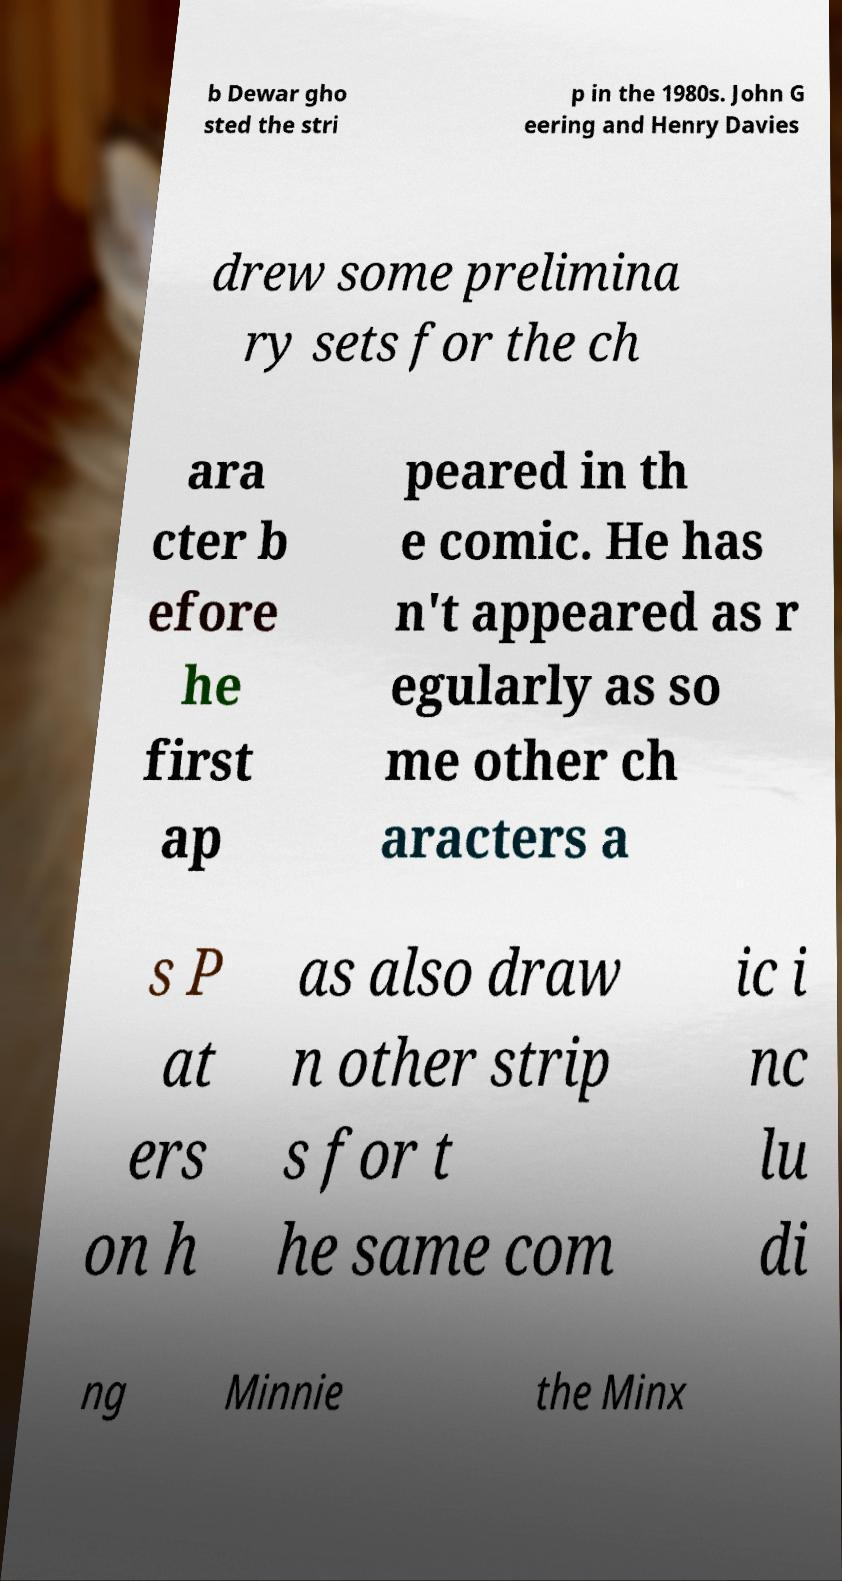Please identify and transcribe the text found in this image. b Dewar gho sted the stri p in the 1980s. John G eering and Henry Davies drew some prelimina ry sets for the ch ara cter b efore he first ap peared in th e comic. He has n't appeared as r egularly as so me other ch aracters a s P at ers on h as also draw n other strip s for t he same com ic i nc lu di ng Minnie the Minx 